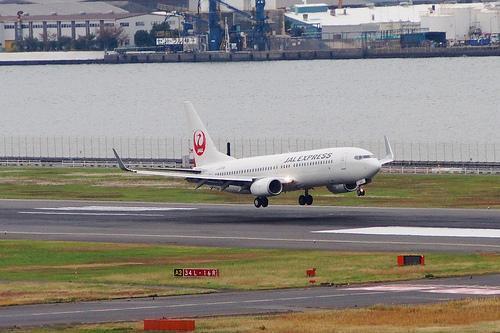How many planes are shown?
Give a very brief answer. 1. 